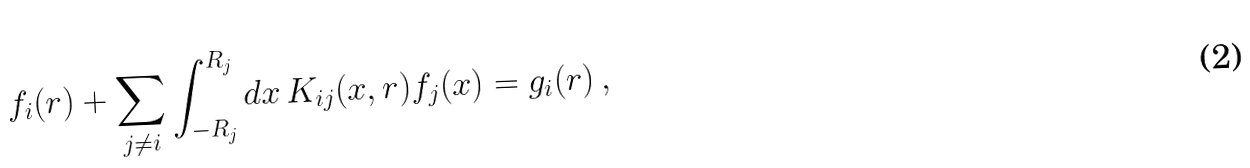Convert formula to latex. <formula><loc_0><loc_0><loc_500><loc_500>f _ { i } ( r ) + \sum _ { j \neq i } \int _ { - R _ { j } } ^ { R _ { j } } d x \, K _ { i j } ( x , r ) f _ { j } ( x ) = g _ { i } ( r ) \, ,</formula> 